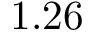<formula> <loc_0><loc_0><loc_500><loc_500>1 . 2 6</formula> 